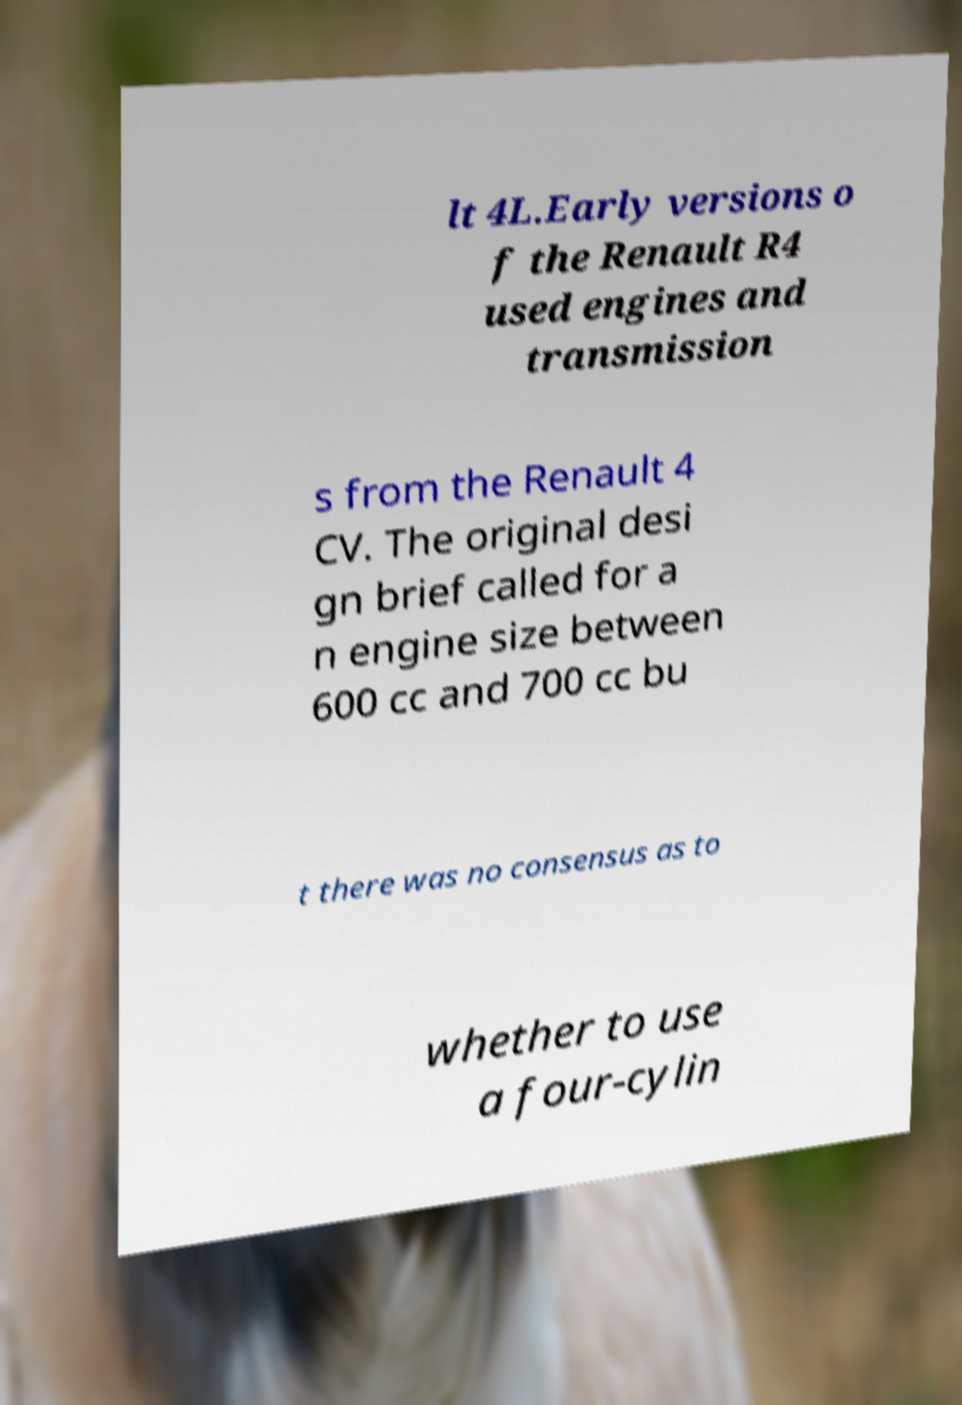Could you extract and type out the text from this image? lt 4L.Early versions o f the Renault R4 used engines and transmission s from the Renault 4 CV. The original desi gn brief called for a n engine size between 600 cc and 700 cc bu t there was no consensus as to whether to use a four-cylin 